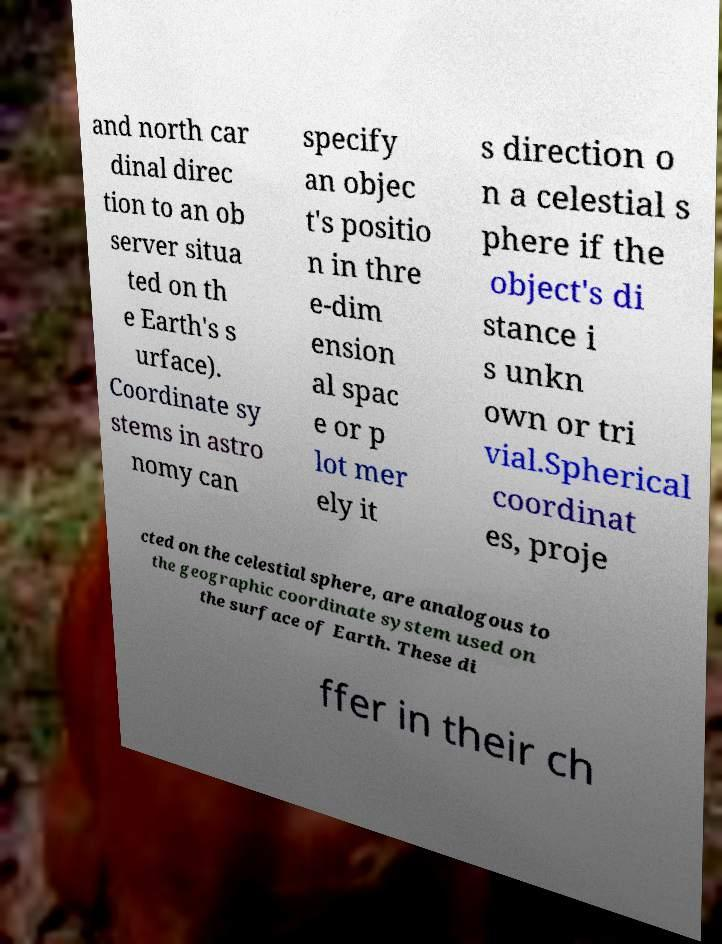For documentation purposes, I need the text within this image transcribed. Could you provide that? and north car dinal direc tion to an ob server situa ted on th e Earth's s urface). Coordinate sy stems in astro nomy can specify an objec t's positio n in thre e-dim ension al spac e or p lot mer ely it s direction o n a celestial s phere if the object's di stance i s unkn own or tri vial.Spherical coordinat es, proje cted on the celestial sphere, are analogous to the geographic coordinate system used on the surface of Earth. These di ffer in their ch 